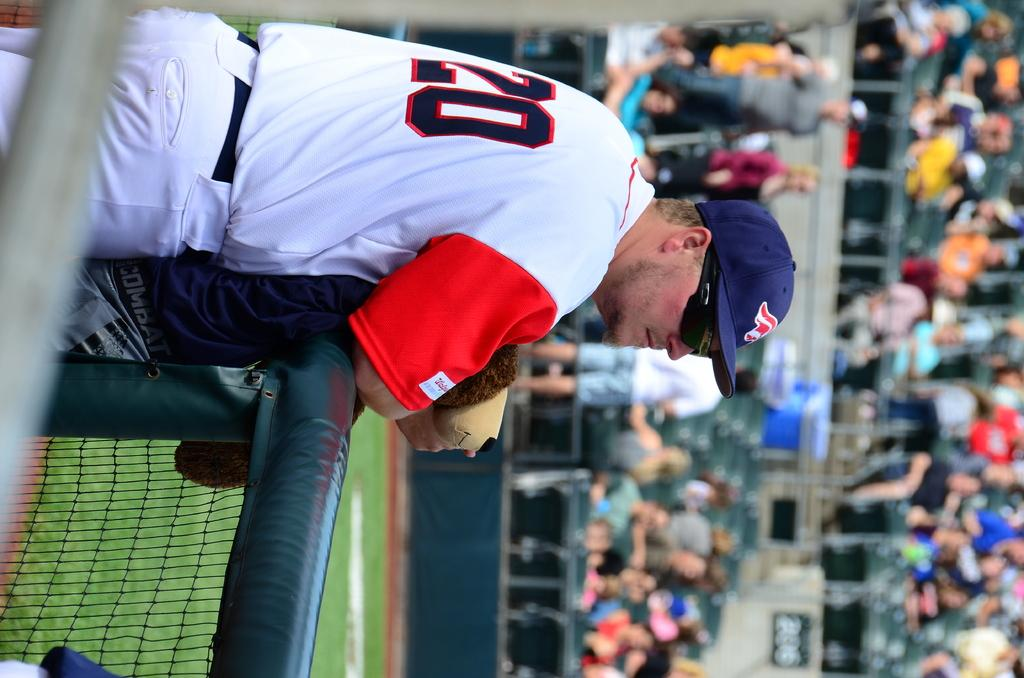<image>
Summarize the visual content of the image. a person with a hat on at a game with the number 20 on 